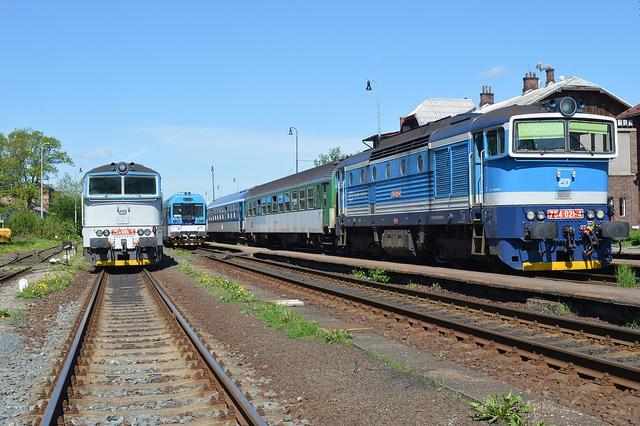Are all the trains going in the same direction?
Give a very brief answer. Yes. How many trains are there?
Write a very short answer. 3. How many tracks are seen?
Answer briefly. 3. Where was the picture taken of the trains?
Write a very short answer. Station. 